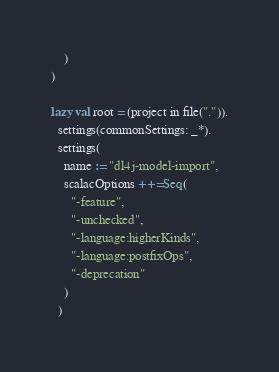<code> <loc_0><loc_0><loc_500><loc_500><_Scala_>    )
)

lazy val root = (project in file(".")).
  settings(commonSettings: _*).
  settings(
    name := "dl4j-model-import",
    scalacOptions ++= Seq(
      "-feature",
      "-unchecked",
      "-language:higherKinds",
      "-language:postfixOps",
      "-deprecation"
    )
  )

</code> 